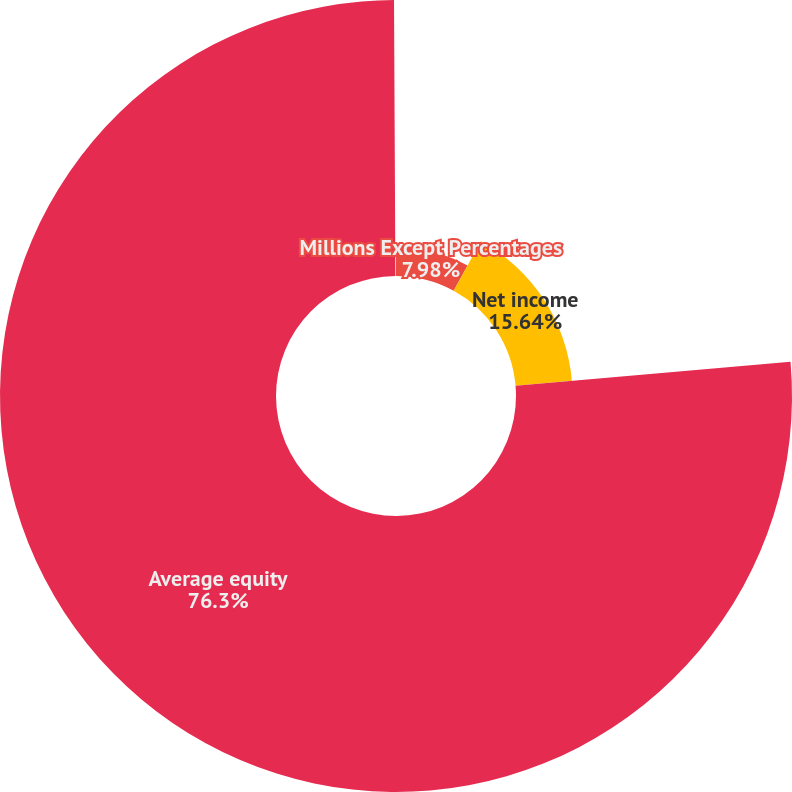Convert chart. <chart><loc_0><loc_0><loc_500><loc_500><pie_chart><fcel>Millions Except Percentages<fcel>Net income<fcel>Average equity<fcel>Return on average common<nl><fcel>7.98%<fcel>15.64%<fcel>76.29%<fcel>0.08%<nl></chart> 